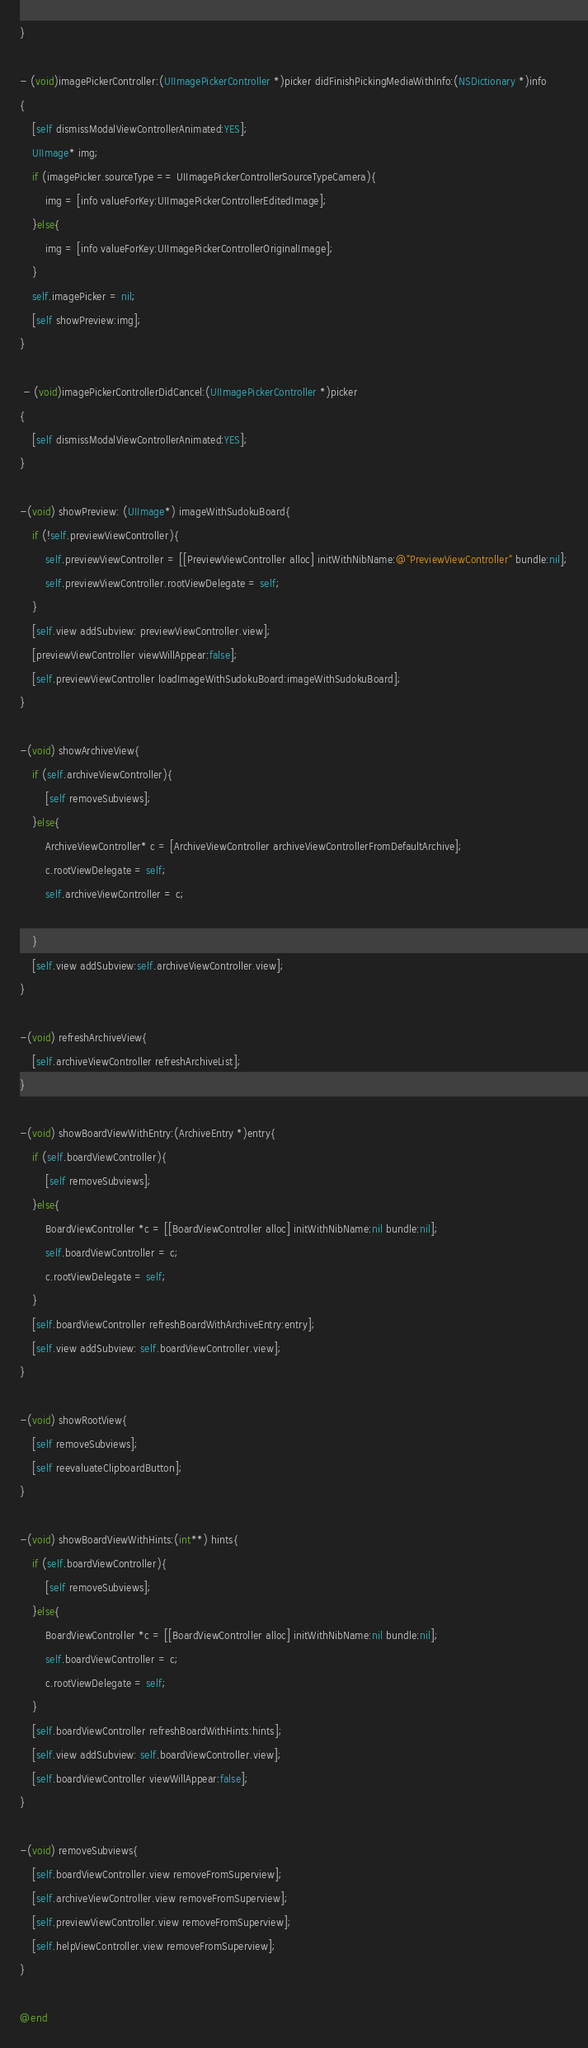Convert code to text. <code><loc_0><loc_0><loc_500><loc_500><_ObjectiveC_>}

- (void)imagePickerController:(UIImagePickerController *)picker didFinishPickingMediaWithInfo:(NSDictionary *)info
{
    [self dismissModalViewControllerAnimated:YES];
    UIImage* img;
    if (imagePicker.sourceType == UIImagePickerControllerSourceTypeCamera){
        img = [info valueForKey:UIImagePickerControllerEditedImage];
    }else{
        img = [info valueForKey:UIImagePickerControllerOriginalImage];
    }
    self.imagePicker = nil;
    [self showPreview:img];
}
 
 - (void)imagePickerControllerDidCancel:(UIImagePickerController *)picker
{
    [self dismissModalViewControllerAnimated:YES];
}

-(void) showPreview: (UIImage*) imageWithSudokuBoard{
    if (!self.previewViewController){
        self.previewViewController = [[PreviewViewController alloc] initWithNibName:@"PreviewViewController" bundle:nil];
        self.previewViewController.rootViewDelegate = self;
    }
    [self.view addSubview: previewViewController.view];
    [previewViewController viewWillAppear:false];
    [self.previewViewController loadImageWithSudokuBoard:imageWithSudokuBoard];
}

-(void) showArchiveView{
    if (self.archiveViewController){
        [self removeSubviews];
    }else{
        ArchiveViewController* c = [ArchiveViewController archiveViewControllerFromDefaultArchive];
        c.rootViewDelegate = self;
        self.archiveViewController = c;
        
    } 
    [self.view addSubview:self.archiveViewController.view];
}

-(void) refreshArchiveView{
    [self.archiveViewController refreshArchiveList];
}

-(void) showBoardViewWithEntry:(ArchiveEntry *)entry{
    if (self.boardViewController){
        [self removeSubviews];
    }else{
        BoardViewController *c = [[BoardViewController alloc] initWithNibName:nil bundle:nil];
        self.boardViewController = c;
        c.rootViewDelegate = self;
    }
    [self.boardViewController refreshBoardWithArchiveEntry:entry];
    [self.view addSubview: self.boardViewController.view];
}

-(void) showRootView{
    [self removeSubviews];
    [self reevaluateClipboardButton];
}

-(void) showBoardViewWithHints:(int**) hints{
    if (self.boardViewController){
        [self removeSubviews];
    }else{
        BoardViewController *c = [[BoardViewController alloc] initWithNibName:nil bundle:nil];
        self.boardViewController = c;
        c.rootViewDelegate = self;
    }
    [self.boardViewController refreshBoardWithHints:hints];    
    [self.view addSubview: self.boardViewController.view];
    [self.boardViewController viewWillAppear:false];
}

-(void) removeSubviews{
    [self.boardViewController.view removeFromSuperview];
    [self.archiveViewController.view removeFromSuperview];
    [self.previewViewController.view removeFromSuperview];
    [self.helpViewController.view removeFromSuperview];
}

@end
</code> 